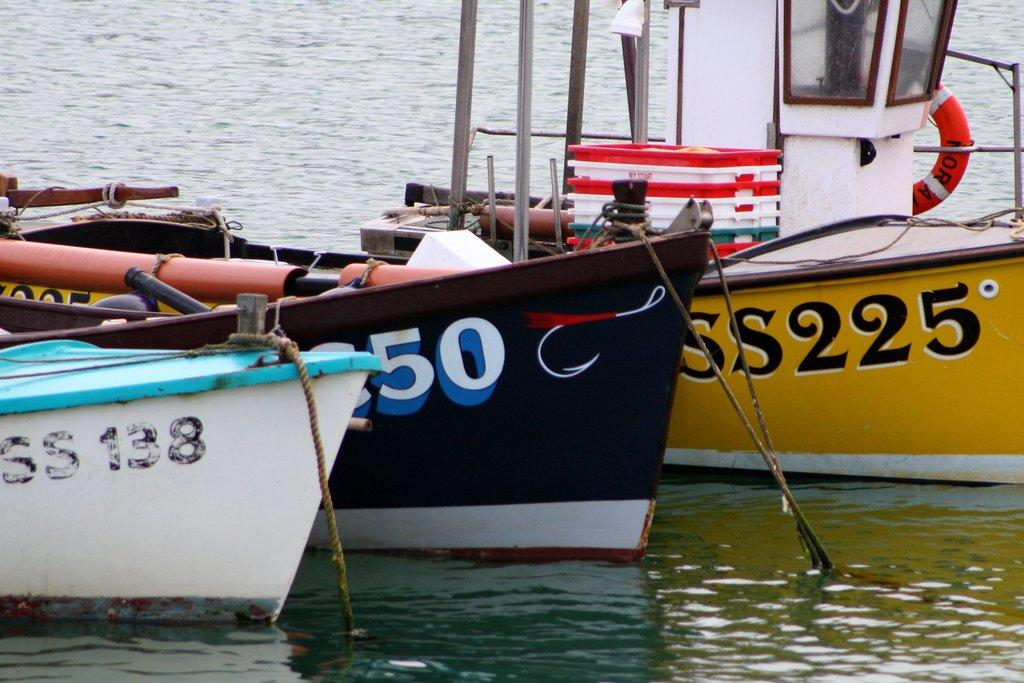What is on the water in the image? There are boats on the water in the image. What can be identified on the boats? The boats have names, rods, and ropes. Are there any other items on the boats? There are other unspecified items on the boats. What shape is the ground in the image? There is no ground visible in the image, as it features boats on the water. 